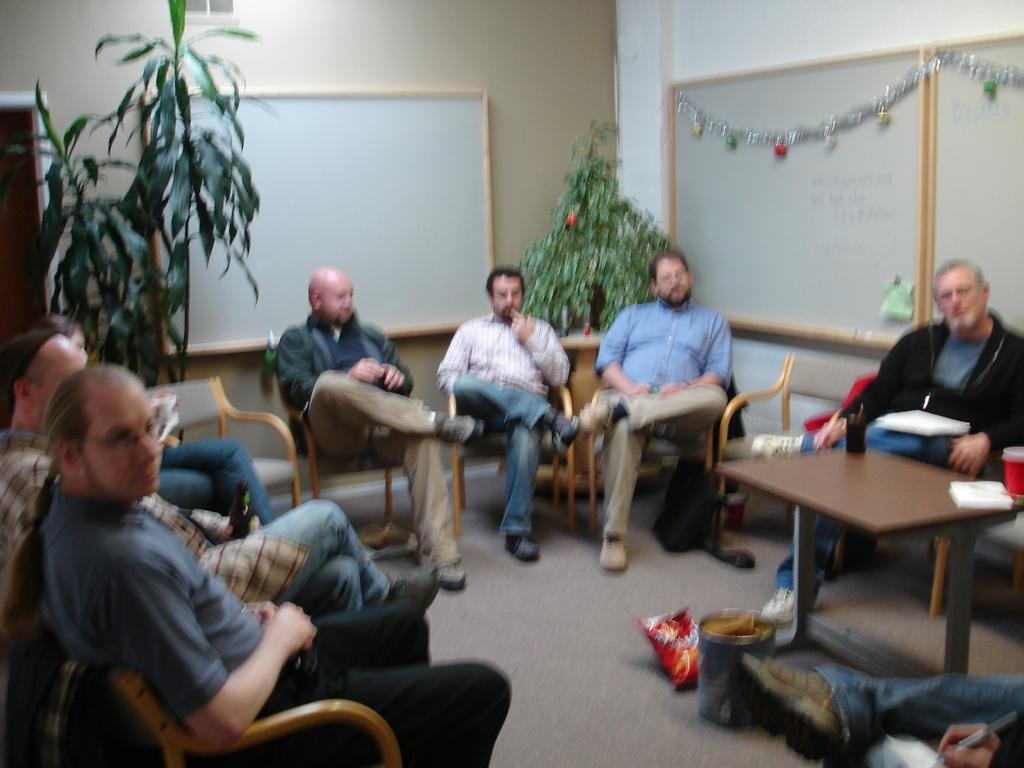What are the people in the image doing? People are sitting on chairs in the image. Where are the chairs located in relation to the table? The chairs are near a table in the image. What can be seen on the table? There is a glass and paper on the table in the image. What can be seen in the background of the image? There is a tree, a whiteboard, and a wall visible in the background of the image. What type of dirt is visible on the whiteboard in the image? There is no dirt visible on the whiteboard in the image. What tax-related information can be seen on the paper on the table? There is no tax-related information present in the image. 